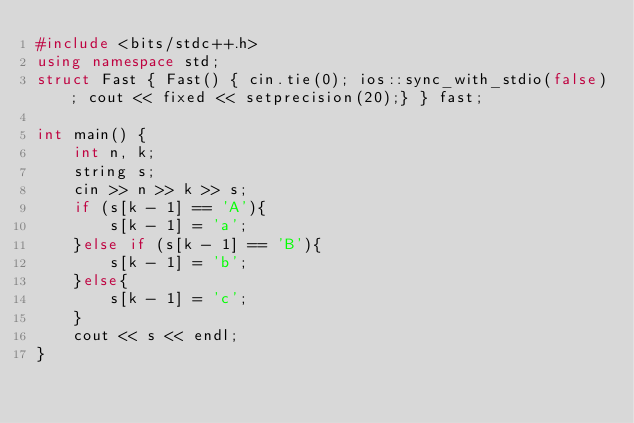Convert code to text. <code><loc_0><loc_0><loc_500><loc_500><_C++_>#include <bits/stdc++.h>
using namespace std;
struct Fast { Fast() { cin.tie(0); ios::sync_with_stdio(false); cout << fixed << setprecision(20);} } fast;

int main() {
    int n, k;
    string s;
    cin >> n >> k >> s;
    if (s[k - 1] == 'A'){
        s[k - 1] = 'a';
    }else if (s[k - 1] == 'B'){
        s[k - 1] = 'b';
    }else{
        s[k - 1] = 'c';
    }
    cout << s << endl;
}</code> 